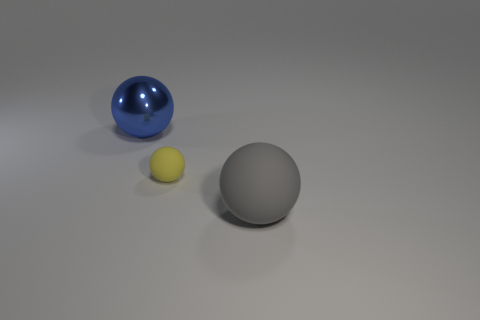Subtract 1 spheres. How many spheres are left? 2 Subtract all gray spheres. How many spheres are left? 2 Add 2 big blue objects. How many objects exist? 5 Add 3 gray balls. How many gray balls exist? 4 Subtract 0 yellow cylinders. How many objects are left? 3 Subtract all green metal cylinders. Subtract all blue spheres. How many objects are left? 2 Add 3 small yellow objects. How many small yellow objects are left? 4 